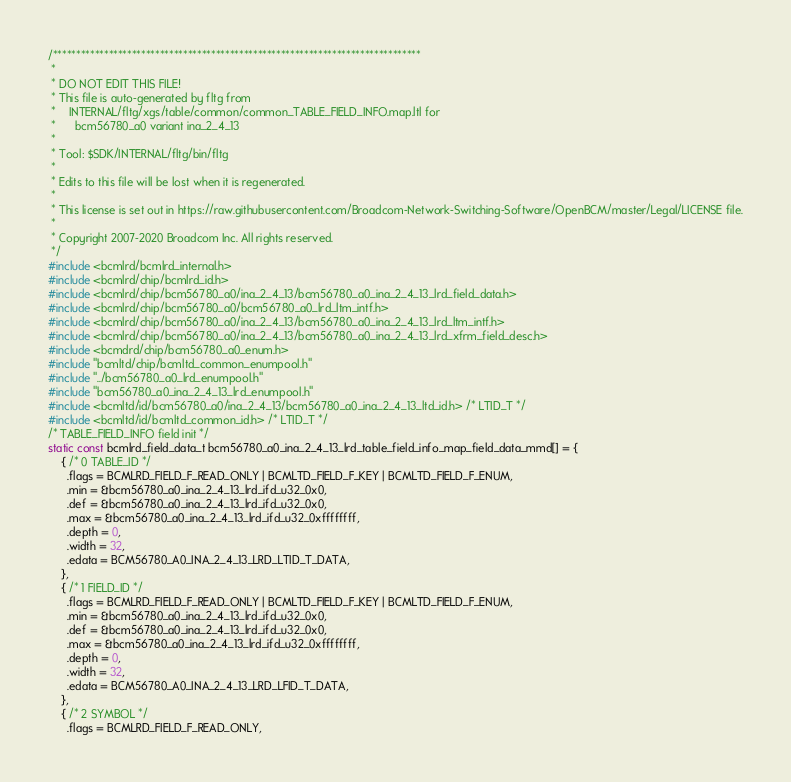Convert code to text. <code><loc_0><loc_0><loc_500><loc_500><_C_>/*******************************************************************************
 *
 * DO NOT EDIT THIS FILE!
 * This file is auto-generated by fltg from
 *    INTERNAL/fltg/xgs/table/common/common_TABLE_FIELD_INFO.map.ltl for
 *      bcm56780_a0 variant ina_2_4_13
 *
 * Tool: $SDK/INTERNAL/fltg/bin/fltg
 *
 * Edits to this file will be lost when it is regenerated.
 *
 * This license is set out in https://raw.githubusercontent.com/Broadcom-Network-Switching-Software/OpenBCM/master/Legal/LICENSE file.
 * 
 * Copyright 2007-2020 Broadcom Inc. All rights reserved.
 */
#include <bcmlrd/bcmlrd_internal.h>
#include <bcmlrd/chip/bcmlrd_id.h>
#include <bcmlrd/chip/bcm56780_a0/ina_2_4_13/bcm56780_a0_ina_2_4_13_lrd_field_data.h>
#include <bcmlrd/chip/bcm56780_a0/bcm56780_a0_lrd_ltm_intf.h>
#include <bcmlrd/chip/bcm56780_a0/ina_2_4_13/bcm56780_a0_ina_2_4_13_lrd_ltm_intf.h>
#include <bcmlrd/chip/bcm56780_a0/ina_2_4_13/bcm56780_a0_ina_2_4_13_lrd_xfrm_field_desc.h>
#include <bcmdrd/chip/bcm56780_a0_enum.h>
#include "bcmltd/chip/bcmltd_common_enumpool.h"
#include "../bcm56780_a0_lrd_enumpool.h"
#include "bcm56780_a0_ina_2_4_13_lrd_enumpool.h"
#include <bcmltd/id/bcm56780_a0/ina_2_4_13/bcm56780_a0_ina_2_4_13_ltd_id.h> /* LTID_T */
#include <bcmltd/id/bcmltd_common_id.h> /* LTID_T */
/* TABLE_FIELD_INFO field init */
static const bcmlrd_field_data_t bcm56780_a0_ina_2_4_13_lrd_table_field_info_map_field_data_mmd[] = {
    { /* 0 TABLE_ID */
      .flags = BCMLRD_FIELD_F_READ_ONLY | BCMLTD_FIELD_F_KEY | BCMLTD_FIELD_F_ENUM,
      .min = &bcm56780_a0_ina_2_4_13_lrd_ifd_u32_0x0,
      .def = &bcm56780_a0_ina_2_4_13_lrd_ifd_u32_0x0,
      .max = &bcm56780_a0_ina_2_4_13_lrd_ifd_u32_0xffffffff,
      .depth = 0,
      .width = 32,
      .edata = BCM56780_A0_INA_2_4_13_LRD_LTID_T_DATA,
    },
    { /* 1 FIELD_ID */
      .flags = BCMLRD_FIELD_F_READ_ONLY | BCMLTD_FIELD_F_KEY | BCMLTD_FIELD_F_ENUM,
      .min = &bcm56780_a0_ina_2_4_13_lrd_ifd_u32_0x0,
      .def = &bcm56780_a0_ina_2_4_13_lrd_ifd_u32_0x0,
      .max = &bcm56780_a0_ina_2_4_13_lrd_ifd_u32_0xffffffff,
      .depth = 0,
      .width = 32,
      .edata = BCM56780_A0_INA_2_4_13_LRD_LFID_T_DATA,
    },
    { /* 2 SYMBOL */
      .flags = BCMLRD_FIELD_F_READ_ONLY,</code> 